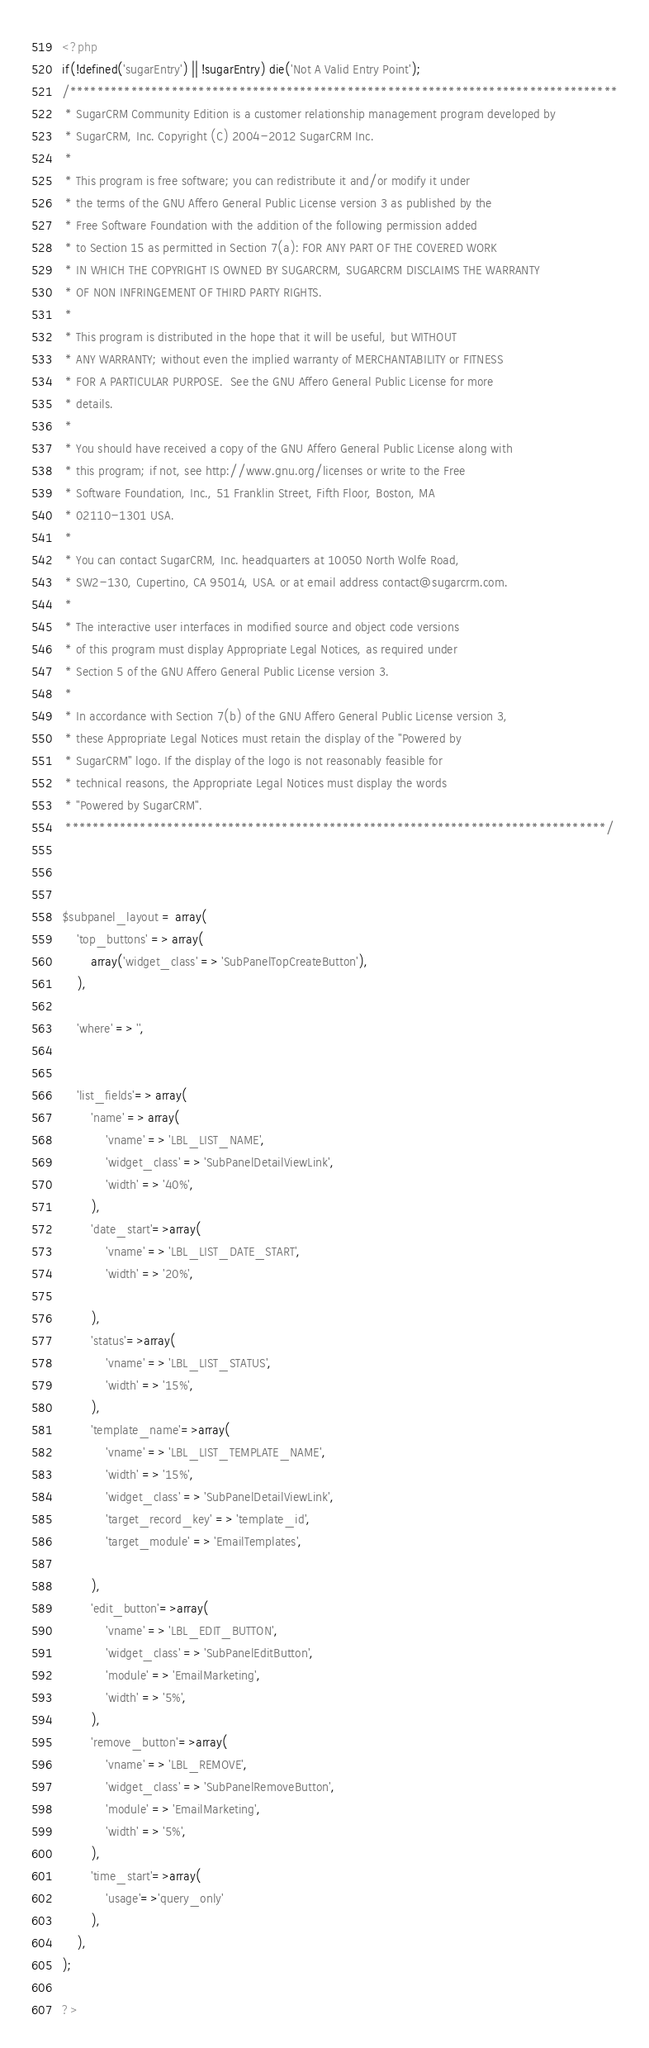<code> <loc_0><loc_0><loc_500><loc_500><_PHP_><?php
if(!defined('sugarEntry') || !sugarEntry) die('Not A Valid Entry Point');
/*********************************************************************************
 * SugarCRM Community Edition is a customer relationship management program developed by
 * SugarCRM, Inc. Copyright (C) 2004-2012 SugarCRM Inc.
 * 
 * This program is free software; you can redistribute it and/or modify it under
 * the terms of the GNU Affero General Public License version 3 as published by the
 * Free Software Foundation with the addition of the following permission added
 * to Section 15 as permitted in Section 7(a): FOR ANY PART OF THE COVERED WORK
 * IN WHICH THE COPYRIGHT IS OWNED BY SUGARCRM, SUGARCRM DISCLAIMS THE WARRANTY
 * OF NON INFRINGEMENT OF THIRD PARTY RIGHTS.
 * 
 * This program is distributed in the hope that it will be useful, but WITHOUT
 * ANY WARRANTY; without even the implied warranty of MERCHANTABILITY or FITNESS
 * FOR A PARTICULAR PURPOSE.  See the GNU Affero General Public License for more
 * details.
 * 
 * You should have received a copy of the GNU Affero General Public License along with
 * this program; if not, see http://www.gnu.org/licenses or write to the Free
 * Software Foundation, Inc., 51 Franklin Street, Fifth Floor, Boston, MA
 * 02110-1301 USA.
 * 
 * You can contact SugarCRM, Inc. headquarters at 10050 North Wolfe Road,
 * SW2-130, Cupertino, CA 95014, USA. or at email address contact@sugarcrm.com.
 * 
 * The interactive user interfaces in modified source and object code versions
 * of this program must display Appropriate Legal Notices, as required under
 * Section 5 of the GNU Affero General Public License version 3.
 * 
 * In accordance with Section 7(b) of the GNU Affero General Public License version 3,
 * these Appropriate Legal Notices must retain the display of the "Powered by
 * SugarCRM" logo. If the display of the logo is not reasonably feasible for
 * technical reasons, the Appropriate Legal Notices must display the words
 * "Powered by SugarCRM".
 ********************************************************************************/



$subpanel_layout = array(
	'top_buttons' => array(
        array('widget_class' => 'SubPanelTopCreateButton'),
	),

	'where' => '',


    'list_fields'=> array(
        'name' => array(
	 		'vname' => 'LBL_LIST_NAME',
			'widget_class' => 'SubPanelDetailViewLink',
		 	'width' => '40%',
		),
		'date_start'=>array(
	 		'vname' => 'LBL_LIST_DATE_START',
		 	'width' => '20%',

		),
		'status'=>array(
	 		'vname' => 'LBL_LIST_STATUS',
		 	'width' => '15%',
		),
		'template_name'=>array(
	 		'vname' => 'LBL_LIST_TEMPLATE_NAME',
		 	'width' => '15%',
			'widget_class' => 'SubPanelDetailViewLink',
		  	'target_record_key' => 'template_id',
		 	'target_module' => 'EmailTemplates',
		 
		),
		'edit_button'=>array(
			'vname' => 'LBL_EDIT_BUTTON',
			'widget_class' => 'SubPanelEditButton',
		 	'module' => 'EmailMarketing',
			'width' => '5%',
		),
		'remove_button'=>array(
			'vname' => 'LBL_REMOVE',
			'widget_class' => 'SubPanelRemoveButton',
		 	'module' => 'EmailMarketing',
			'width' => '5%',
		),
	 	'time_start'=>array(
	 		'usage'=>'query_only'
 		),
	),
);

?></code> 